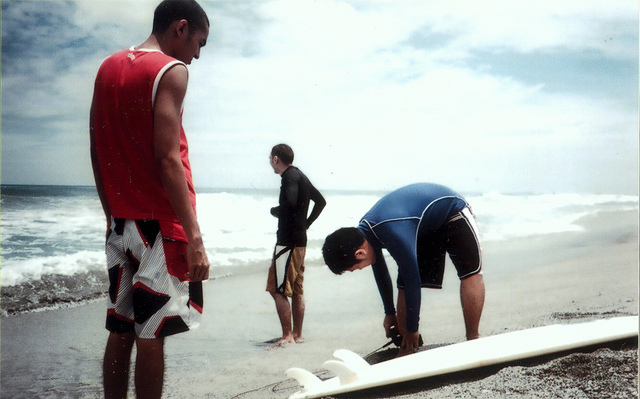What activities are the boys in the photo doing? The first boy standing in the red tank top appears to be observing the ocean, possibly checking the surf conditions. The second, in a black wetsuit, is standing with hands on his waist, also looking contemplative, perhaps gauging the water before entering it. The third boy is crouched near a surfboard, appearing to attach or adjust the surfboard's leash, preparing for a surfing session. 